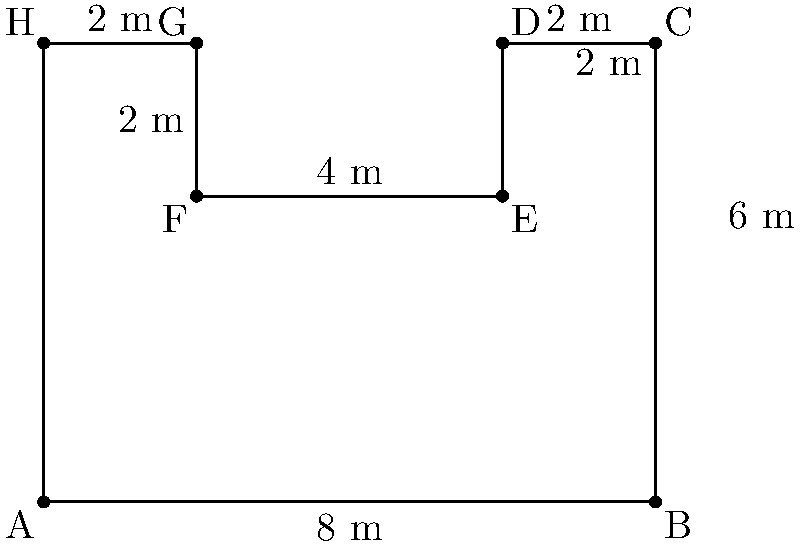A traditional Korean hanok house has a floor plan shaped like the figure above. Calculate the perimeter of this hanok's floor plan in meters. To find the perimeter, we need to add up all the sides of the floor plan:

1. Bottom side (AB): $8$ m
2. Right side (BC): $6$ m
3. Top-right side (CD): $2$ m
4. Right inner side (DE): $2$ m
5. Top-middle side (EF): $4$ m
6. Left inner side (FG): $2$ m
7. Top-left side (GH): $2$ m
8. Left side (HA): $6$ m

Adding all these lengths:

$$\text{Perimeter} = 8 + 6 + 2 + 2 + 4 + 2 + 2 + 6 = 32\text{ m}$$

Therefore, the perimeter of the hanok's floor plan is $32$ meters.
Answer: $32\text{ m}$ 